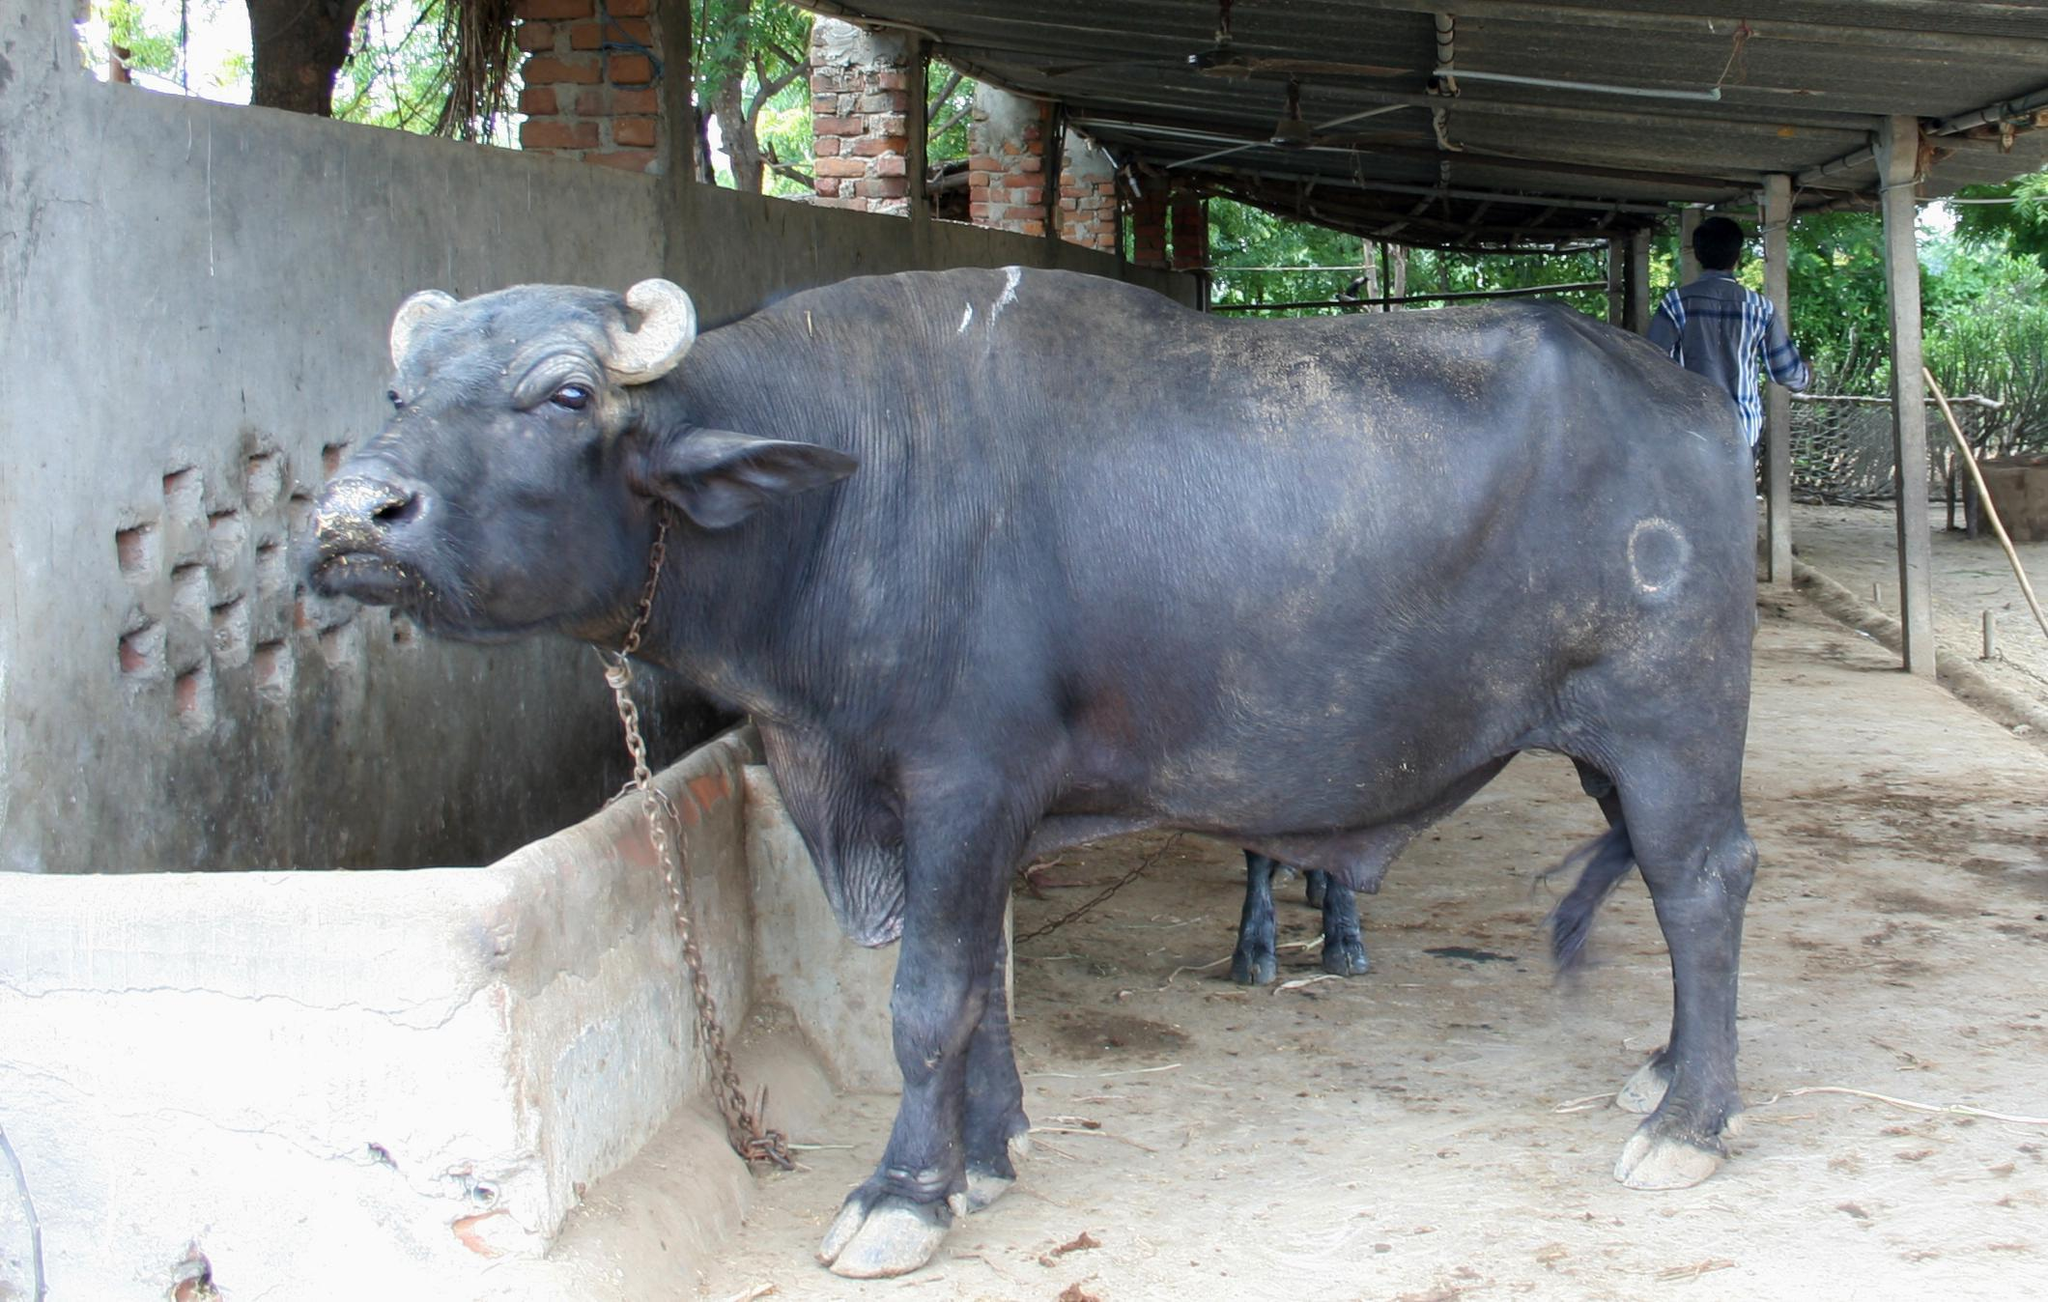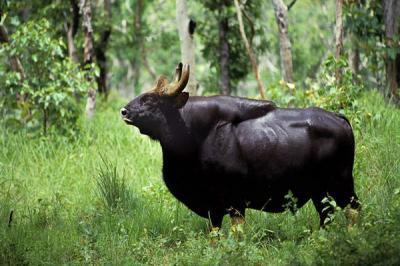The first image is the image on the left, the second image is the image on the right. Evaluate the accuracy of this statement regarding the images: "A non-standing hunter holding a weapon is behind a killed water buffalo that is lying on the ground with its face forward.". Is it true? Answer yes or no. No. The first image is the image on the left, the second image is the image on the right. Analyze the images presented: Is the assertion "The right image contains a dead water buffalo in front of a human." valid? Answer yes or no. No. 